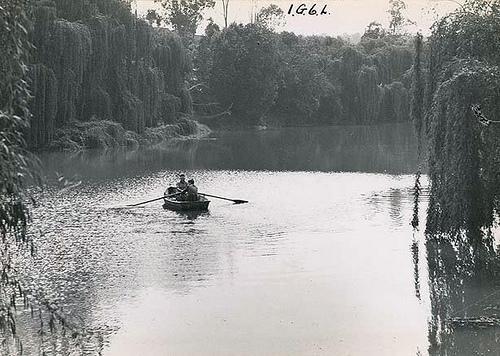How many boats are shown?
Give a very brief answer. 1. How many people are standing outside the train in the image?
Give a very brief answer. 0. 